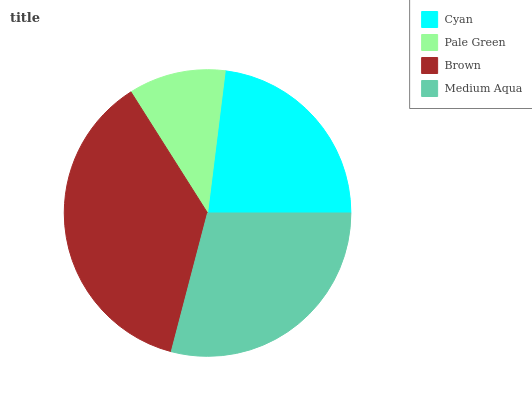Is Pale Green the minimum?
Answer yes or no. Yes. Is Brown the maximum?
Answer yes or no. Yes. Is Brown the minimum?
Answer yes or no. No. Is Pale Green the maximum?
Answer yes or no. No. Is Brown greater than Pale Green?
Answer yes or no. Yes. Is Pale Green less than Brown?
Answer yes or no. Yes. Is Pale Green greater than Brown?
Answer yes or no. No. Is Brown less than Pale Green?
Answer yes or no. No. Is Medium Aqua the high median?
Answer yes or no. Yes. Is Cyan the low median?
Answer yes or no. Yes. Is Brown the high median?
Answer yes or no. No. Is Brown the low median?
Answer yes or no. No. 